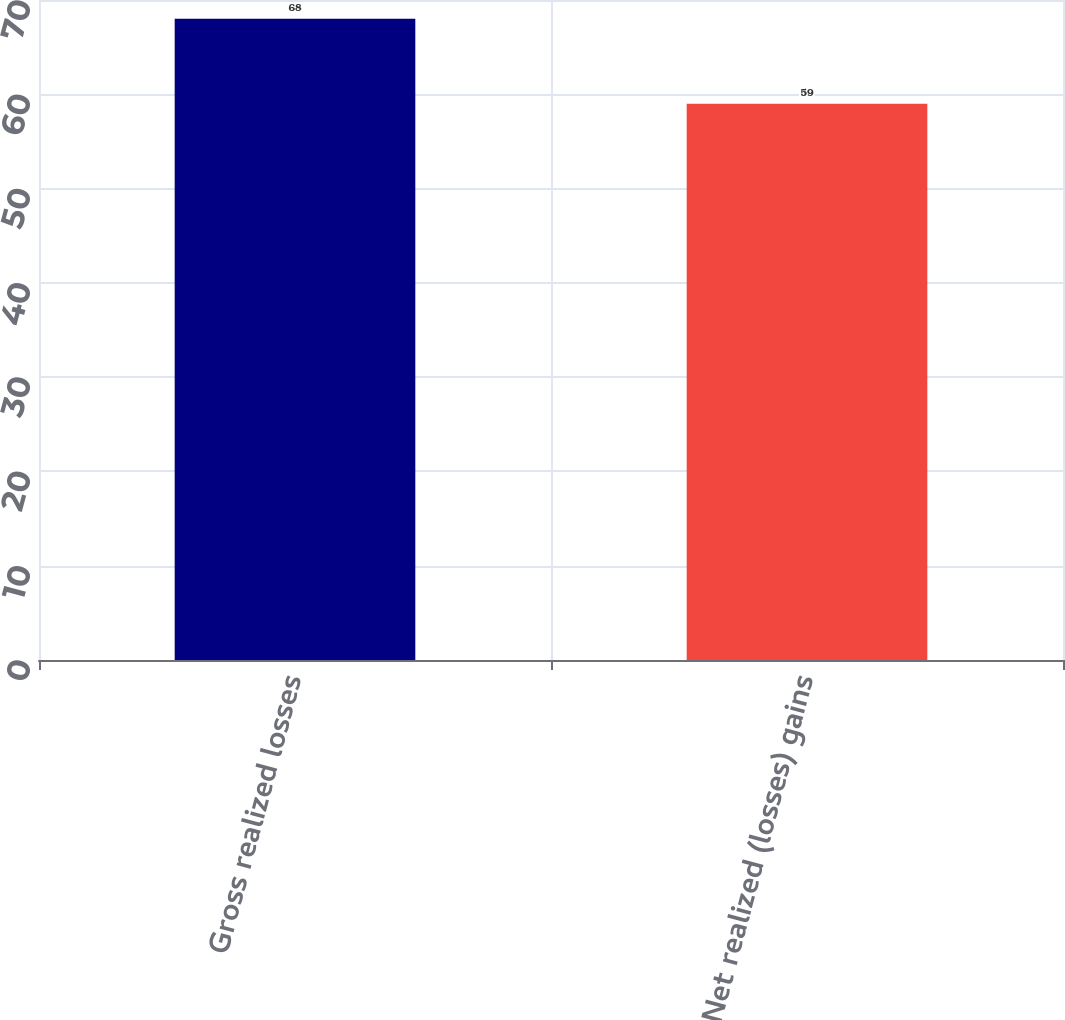Convert chart. <chart><loc_0><loc_0><loc_500><loc_500><bar_chart><fcel>Gross realized losses<fcel>Net realized (losses) gains<nl><fcel>68<fcel>59<nl></chart> 